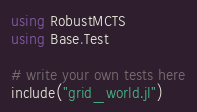<code> <loc_0><loc_0><loc_500><loc_500><_Julia_>using RobustMCTS
using Base.Test

# write your own tests here
include("grid_world.jl")
</code> 